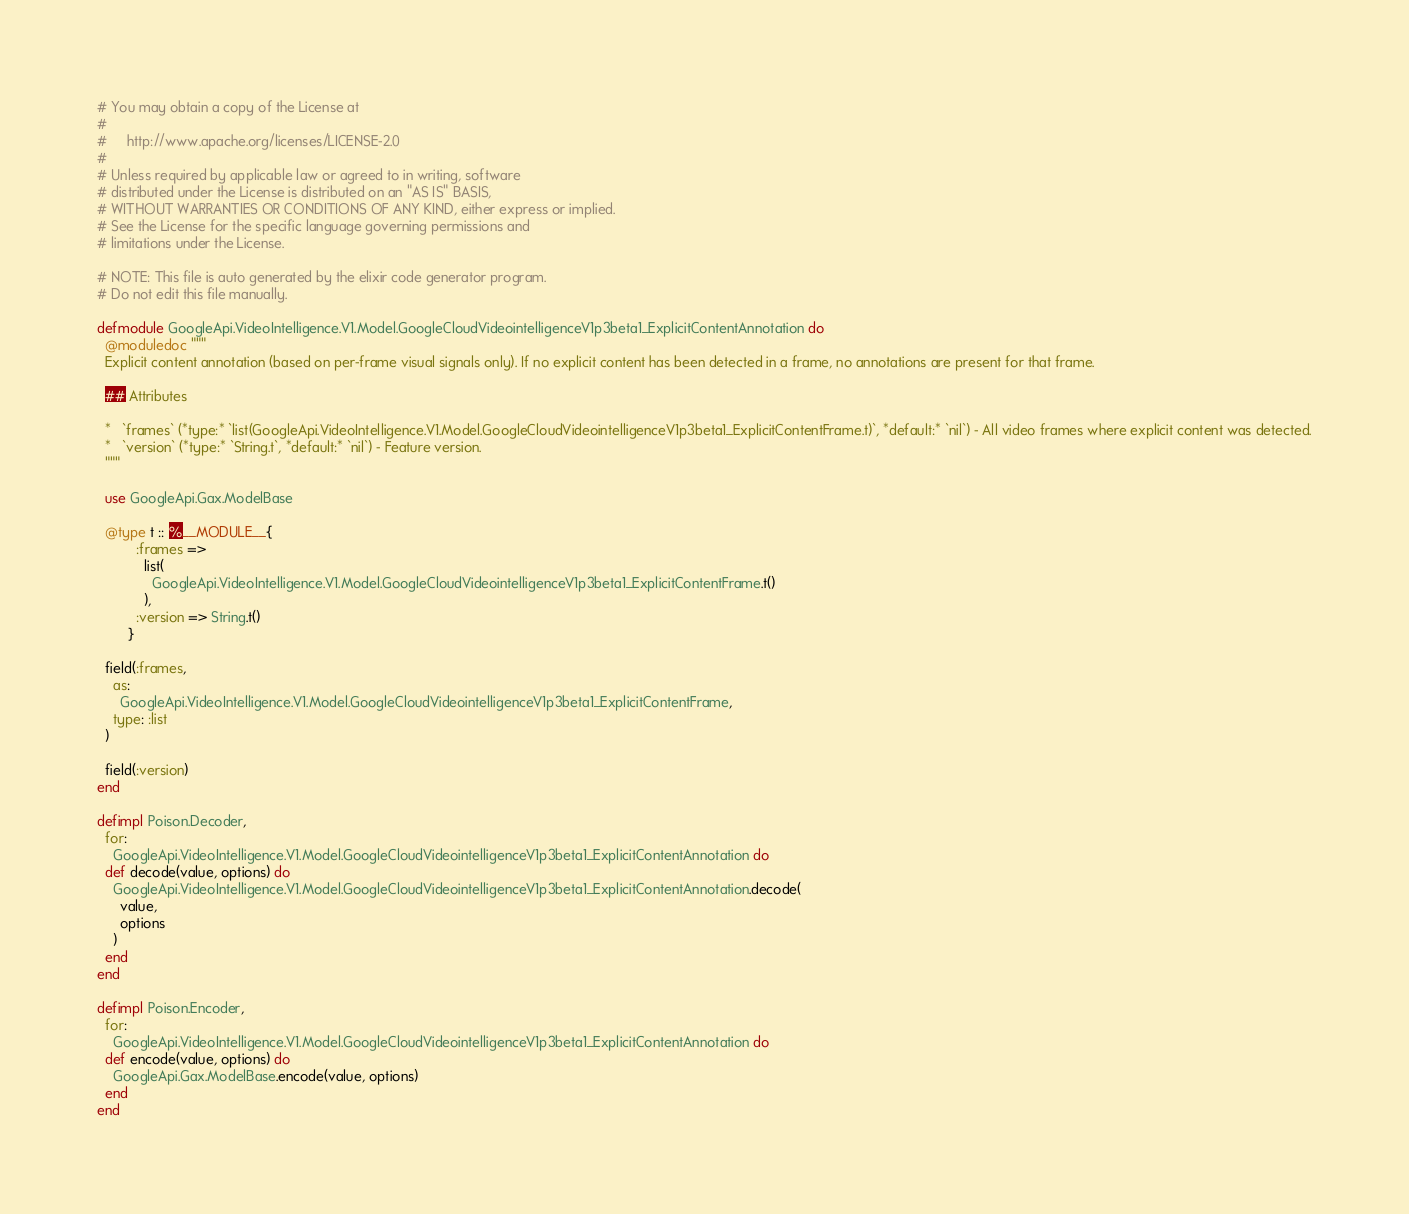Convert code to text. <code><loc_0><loc_0><loc_500><loc_500><_Elixir_># You may obtain a copy of the License at
#
#     http://www.apache.org/licenses/LICENSE-2.0
#
# Unless required by applicable law or agreed to in writing, software
# distributed under the License is distributed on an "AS IS" BASIS,
# WITHOUT WARRANTIES OR CONDITIONS OF ANY KIND, either express or implied.
# See the License for the specific language governing permissions and
# limitations under the License.

# NOTE: This file is auto generated by the elixir code generator program.
# Do not edit this file manually.

defmodule GoogleApi.VideoIntelligence.V1.Model.GoogleCloudVideointelligenceV1p3beta1_ExplicitContentAnnotation do
  @moduledoc """
  Explicit content annotation (based on per-frame visual signals only). If no explicit content has been detected in a frame, no annotations are present for that frame.

  ## Attributes

  *   `frames` (*type:* `list(GoogleApi.VideoIntelligence.V1.Model.GoogleCloudVideointelligenceV1p3beta1_ExplicitContentFrame.t)`, *default:* `nil`) - All video frames where explicit content was detected.
  *   `version` (*type:* `String.t`, *default:* `nil`) - Feature version.
  """

  use GoogleApi.Gax.ModelBase

  @type t :: %__MODULE__{
          :frames =>
            list(
              GoogleApi.VideoIntelligence.V1.Model.GoogleCloudVideointelligenceV1p3beta1_ExplicitContentFrame.t()
            ),
          :version => String.t()
        }

  field(:frames,
    as:
      GoogleApi.VideoIntelligence.V1.Model.GoogleCloudVideointelligenceV1p3beta1_ExplicitContentFrame,
    type: :list
  )

  field(:version)
end

defimpl Poison.Decoder,
  for:
    GoogleApi.VideoIntelligence.V1.Model.GoogleCloudVideointelligenceV1p3beta1_ExplicitContentAnnotation do
  def decode(value, options) do
    GoogleApi.VideoIntelligence.V1.Model.GoogleCloudVideointelligenceV1p3beta1_ExplicitContentAnnotation.decode(
      value,
      options
    )
  end
end

defimpl Poison.Encoder,
  for:
    GoogleApi.VideoIntelligence.V1.Model.GoogleCloudVideointelligenceV1p3beta1_ExplicitContentAnnotation do
  def encode(value, options) do
    GoogleApi.Gax.ModelBase.encode(value, options)
  end
end
</code> 